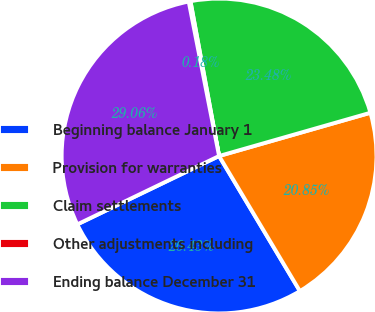<chart> <loc_0><loc_0><loc_500><loc_500><pie_chart><fcel>Beginning balance January 1<fcel>Provision for warranties<fcel>Claim settlements<fcel>Other adjustments including<fcel>Ending balance December 31<nl><fcel>26.43%<fcel>20.85%<fcel>23.48%<fcel>0.18%<fcel>29.06%<nl></chart> 